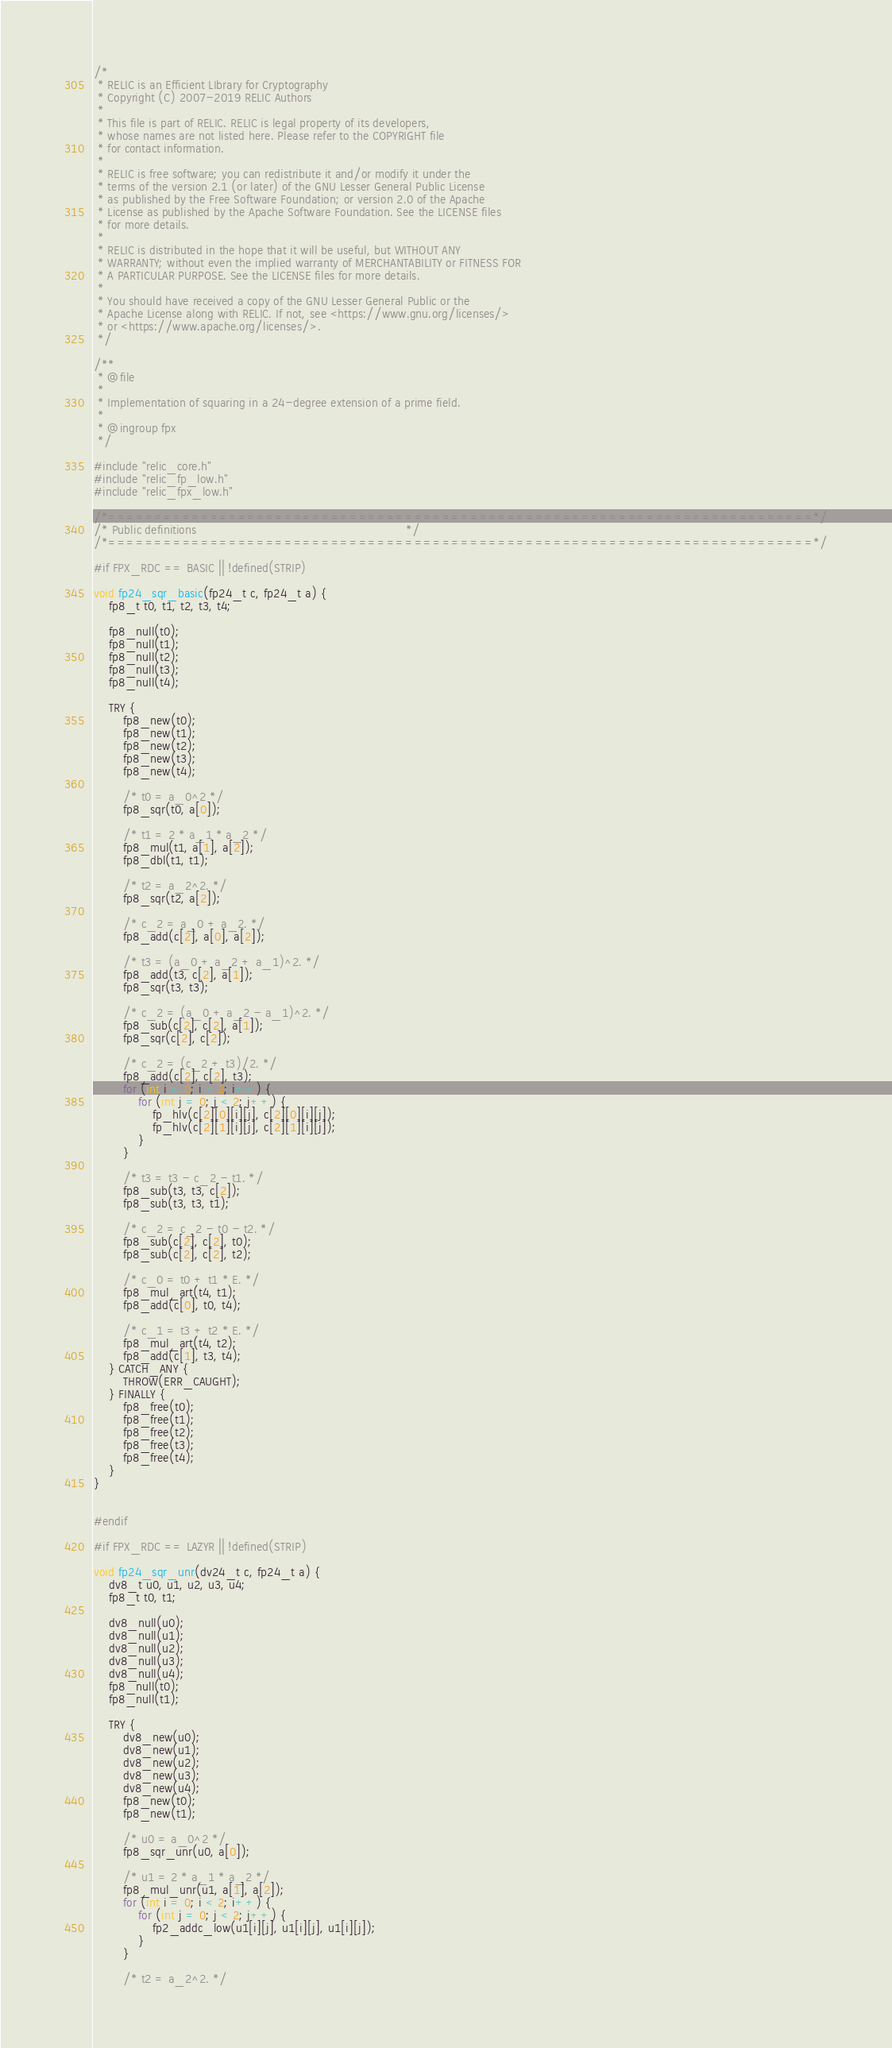<code> <loc_0><loc_0><loc_500><loc_500><_C_>/*
 * RELIC is an Efficient LIbrary for Cryptography
 * Copyright (C) 2007-2019 RELIC Authors
 *
 * This file is part of RELIC. RELIC is legal property of its developers,
 * whose names are not listed here. Please refer to the COPYRIGHT file
 * for contact information.
 *
 * RELIC is free software; you can redistribute it and/or modify it under the
 * terms of the version 2.1 (or later) of the GNU Lesser General Public License
 * as published by the Free Software Foundation; or version 2.0 of the Apache
 * License as published by the Apache Software Foundation. See the LICENSE files
 * for more details.
 *
 * RELIC is distributed in the hope that it will be useful, but WITHOUT ANY
 * WARRANTY; without even the implied warranty of MERCHANTABILITY or FITNESS FOR
 * A PARTICULAR PURPOSE. See the LICENSE files for more details.
 *
 * You should have received a copy of the GNU Lesser General Public or the
 * Apache License along with RELIC. If not, see <https://www.gnu.org/licenses/>
 * or <https://www.apache.org/licenses/>.
 */

/**
 * @file
 *
 * Implementation of squaring in a 24-degree extension of a prime field.
 *
 * @ingroup fpx
 */

#include "relic_core.h"
#include "relic_fp_low.h"
#include "relic_fpx_low.h"

/*============================================================================*/
/* Public definitions                                                         */
/*============================================================================*/

#if FPX_RDC == BASIC || !defined(STRIP)

void fp24_sqr_basic(fp24_t c, fp24_t a) {
	fp8_t t0, t1, t2, t3, t4;

	fp8_null(t0);
	fp8_null(t1);
	fp8_null(t2);
	fp8_null(t3);
	fp8_null(t4);

	TRY {
		fp8_new(t0);
		fp8_new(t1);
		fp8_new(t2);
		fp8_new(t3);
		fp8_new(t4);

		/* t0 = a_0^2 */
		fp8_sqr(t0, a[0]);

		/* t1 = 2 * a_1 * a_2 */
		fp8_mul(t1, a[1], a[2]);
		fp8_dbl(t1, t1);

		/* t2 = a_2^2. */
		fp8_sqr(t2, a[2]);

		/* c_2 = a_0 + a_2. */
		fp8_add(c[2], a[0], a[2]);

		/* t3 = (a_0 + a_2 + a_1)^2. */
		fp8_add(t3, c[2], a[1]);
		fp8_sqr(t3, t3);

		/* c_2 = (a_0 + a_2 - a_1)^2. */
		fp8_sub(c[2], c[2], a[1]);
		fp8_sqr(c[2], c[2]);

		/* c_2 = (c_2 + t3)/2. */
		fp8_add(c[2], c[2], t3);
		for (int i = 0; i < 2; i++) {
			for (int j = 0; j < 2; j++) {
				fp_hlv(c[2][0][i][j], c[2][0][i][j]);
				fp_hlv(c[2][1][i][j], c[2][1][i][j]);
			}
		}

		/* t3 = t3 - c_2 - t1. */
		fp8_sub(t3, t3, c[2]);
		fp8_sub(t3, t3, t1);

		/* c_2 = c_2 - t0 - t2. */
		fp8_sub(c[2], c[2], t0);
		fp8_sub(c[2], c[2], t2);

		/* c_0 = t0 + t1 * E. */
		fp8_mul_art(t4, t1);
		fp8_add(c[0], t0, t4);

		/* c_1 = t3 + t2 * E. */
		fp8_mul_art(t4, t2);
		fp8_add(c[1], t3, t4);
	} CATCH_ANY {
		THROW(ERR_CAUGHT);
	} FINALLY {
		fp8_free(t0);
		fp8_free(t1);
		fp8_free(t2);
		fp8_free(t3);
		fp8_free(t4);
	}
}


#endif

#if FPX_RDC == LAZYR || !defined(STRIP)

void fp24_sqr_unr(dv24_t c, fp24_t a) {
	dv8_t u0, u1, u2, u3, u4;
	fp8_t t0, t1;

	dv8_null(u0);
	dv8_null(u1);
	dv8_null(u2);
	dv8_null(u3);
	dv8_null(u4);
	fp8_null(t0);
	fp8_null(t1);

	TRY {
		dv8_new(u0);
		dv8_new(u1);
		dv8_new(u2);
		dv8_new(u3);
		dv8_new(u4);
		fp8_new(t0);
		fp8_new(t1);

		/* u0 = a_0^2 */
		fp8_sqr_unr(u0, a[0]);

		/* u1 = 2 * a_1 * a_2 */
		fp8_mul_unr(u1, a[1], a[2]);
		for (int i = 0; i < 2; i++) {
			for (int j = 0; j < 2; j++) {
				fp2_addc_low(u1[i][j], u1[i][j], u1[i][j]);
			}
		}

		/* t2 = a_2^2. */</code> 